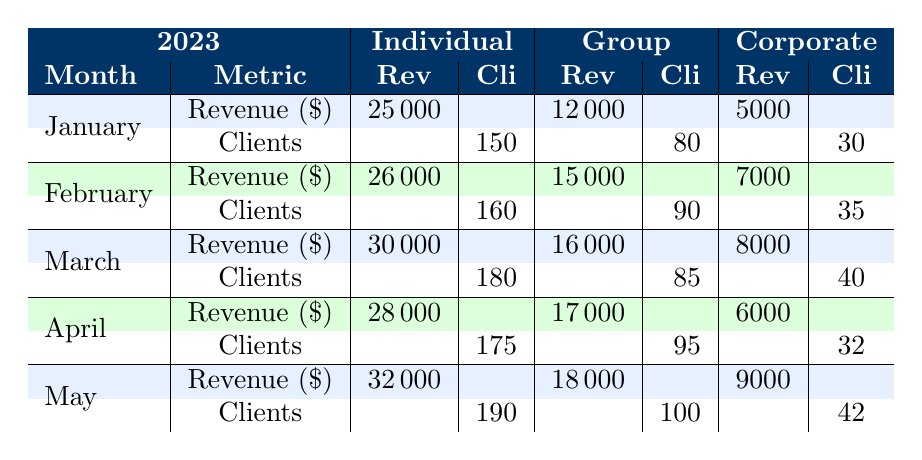What's the total revenue generated from individual clients in March? The revenue from individual clients in March is listed as $30,000.
Answer: 30000 How many clients participated in group clinics during January? The number of clients for group clinics in January is 80, as shown in the table.
Answer: 80 What is the revenue difference between individual and corporate clinics in April? In April, individual clinics generated $28,000 and corporate clinics generated $6,000. The difference is calculated as $28,000 - $6,000 = $22,000.
Answer: 22000 Did corporate clinic revenue increase from January to February? In January, corporate clinic revenue was $5,000, and in February, it increased to $7,000. Hence, it did increase.
Answer: Yes What was the average revenue from group clinics over the first five months of 2023? The group clinic revenues for the first five months are $12,000 (Jan) + $15,000 (Feb) + $16,000 (Mar) + $17,000 (Apr) + $18,000 (May) = $78,000. The average revenue is $78,000 / 5 = $15,600.
Answer: 15600 Which month had the highest number of individual clients? The month with the highest number of individual clients is May, with 190 clients.
Answer: May Calculate the total revenue from all types of clinics in February. February's total revenue is the sum of individual ($26,000) + group ($15,000) + corporate ($7,000) = $48,000.
Answer: 48000 Do individual clinics consistently generate more revenue than corporate clinics throughout the five months? Yes, in all five months, the revenue from individual clinics is greater than corporate clinics: January ($25,000 vs. $5,000), February ($26,000 vs. $7,000), March ($30,000 vs. $8,000), April ($28,000 vs. $6,000), and May ($32,000 vs. $9,000).
Answer: Yes What is the total number of clients served in group clinics from January to May? The total number of clients in group clinics is calculated as 80 (Jan) + 90 (Feb) + 85 (Mar) + 95 (Apr) + 100 (May) = 450 clients.
Answer: 450 